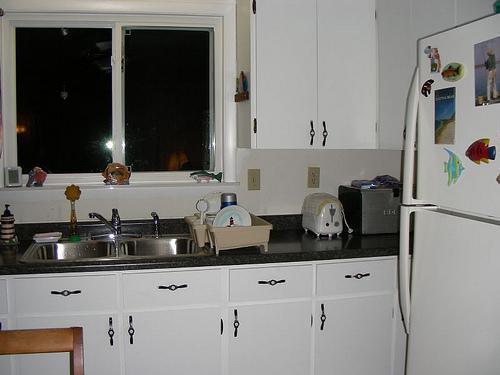How many chairs are there?
Give a very brief answer. 1. 